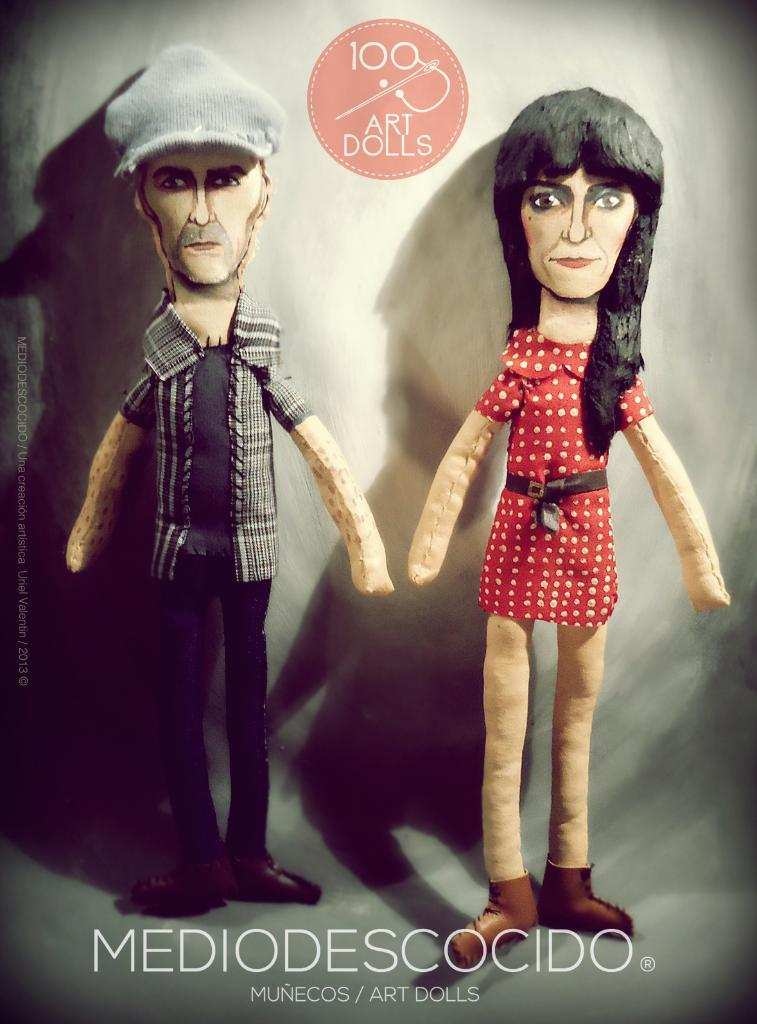What style is the image in? The image is a cartoon. How many people are in the image? There is a man and a woman in the image. Is there any text present in the image? Yes, there is text at the bottom of the picture and a logo with text on the top of the picture. What type of fowl can be seen flying in the image? There is no fowl present in the image; it is a cartoon featuring a man and a woman. Can you describe how the creator of the cartoon stretched the characters' limbs in the image? The image is a cartoon, but there is no information provided about the creator or the stretching of characters' limbs. 